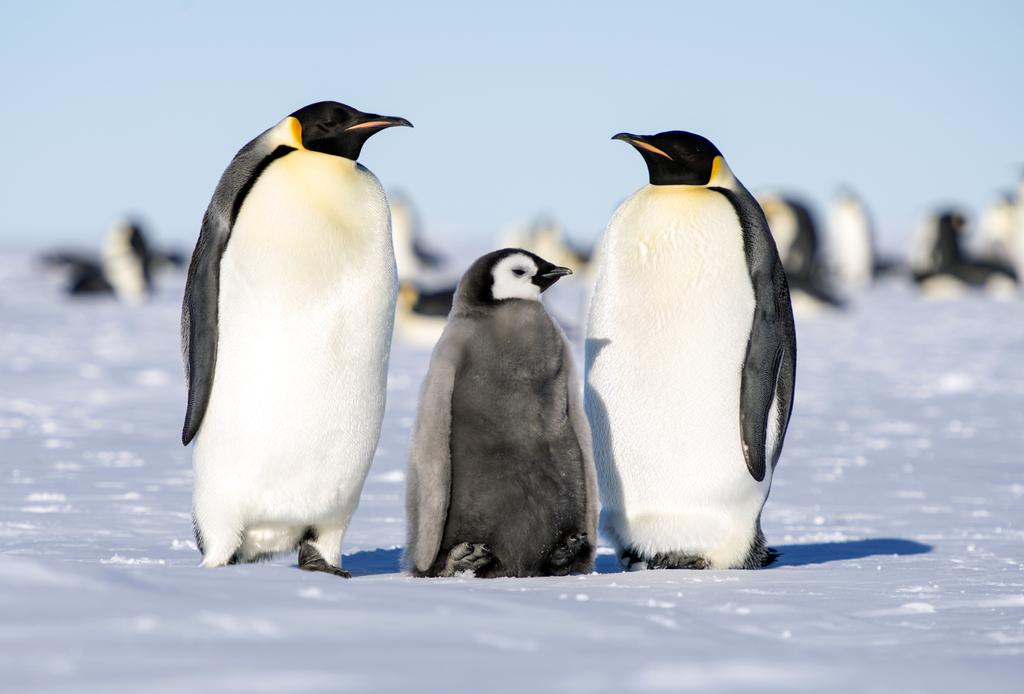What type of animals are in the image? There are penguins in the image. What is the ground made of in the image? There is snow at the bottom of the image. What type of cub can be seen playing with a cracker in the image? There is no cub or cracker present in the image; it features penguins in a snowy environment. What is the texture of the penguins' feathers in the image? The provided facts do not mention the texture of the penguins' feathers, so it cannot be determined from the image. 